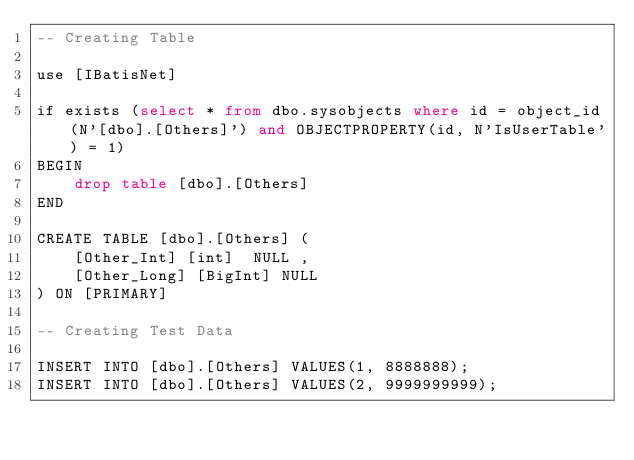<code> <loc_0><loc_0><loc_500><loc_500><_SQL_>-- Creating Table

use [IBatisNet]

if exists (select * from dbo.sysobjects where id = object_id(N'[dbo].[Others]') and OBJECTPROPERTY(id, N'IsUserTable') = 1)
BEGIN
	drop table [dbo].[Others]
END

CREATE TABLE [dbo].[Others] (
	[Other_Int] [int]  NULL ,
	[Other_Long] [BigInt] NULL
) ON [PRIMARY]

-- Creating Test Data

INSERT INTO [dbo].[Others] VALUES(1, 8888888);
INSERT INTO [dbo].[Others] VALUES(2, 9999999999);</code> 